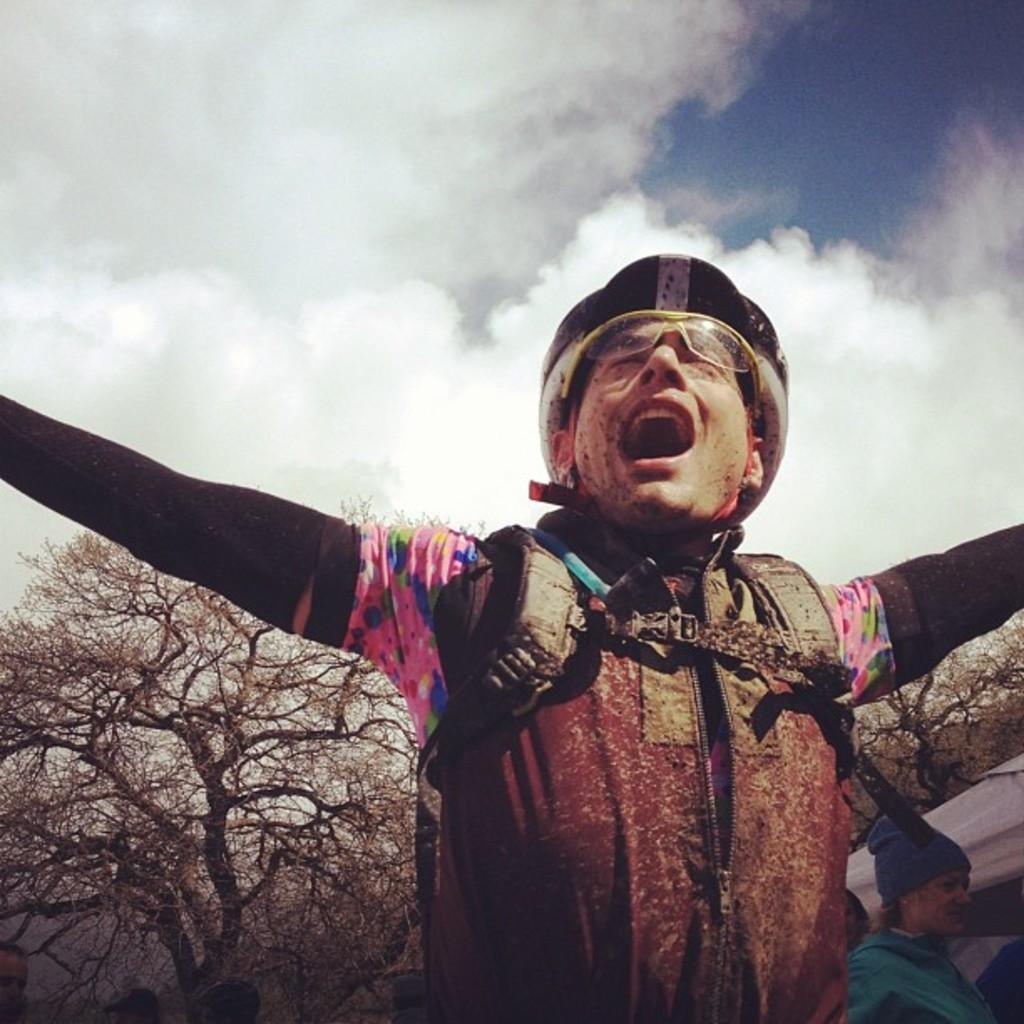How would you summarize this image in a sentence or two? In this picture I can see a man with a helmet, there is another person, there are trees, and in the background there is the sky. 